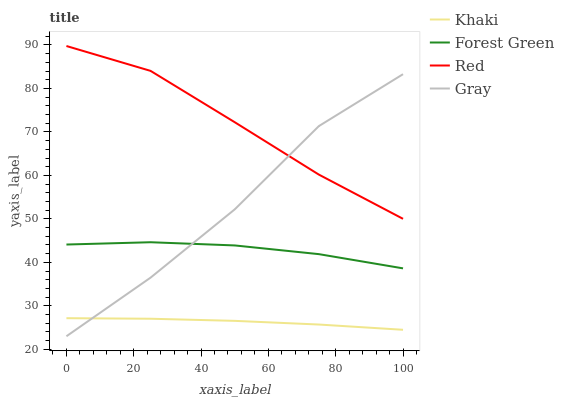Does Khaki have the minimum area under the curve?
Answer yes or no. Yes. Does Red have the maximum area under the curve?
Answer yes or no. Yes. Does Forest Green have the minimum area under the curve?
Answer yes or no. No. Does Forest Green have the maximum area under the curve?
Answer yes or no. No. Is Khaki the smoothest?
Answer yes or no. Yes. Is Gray the roughest?
Answer yes or no. Yes. Is Forest Green the smoothest?
Answer yes or no. No. Is Forest Green the roughest?
Answer yes or no. No. Does Gray have the lowest value?
Answer yes or no. Yes. Does Forest Green have the lowest value?
Answer yes or no. No. Does Red have the highest value?
Answer yes or no. Yes. Does Forest Green have the highest value?
Answer yes or no. No. Is Forest Green less than Red?
Answer yes or no. Yes. Is Red greater than Forest Green?
Answer yes or no. Yes. Does Forest Green intersect Gray?
Answer yes or no. Yes. Is Forest Green less than Gray?
Answer yes or no. No. Is Forest Green greater than Gray?
Answer yes or no. No. Does Forest Green intersect Red?
Answer yes or no. No. 